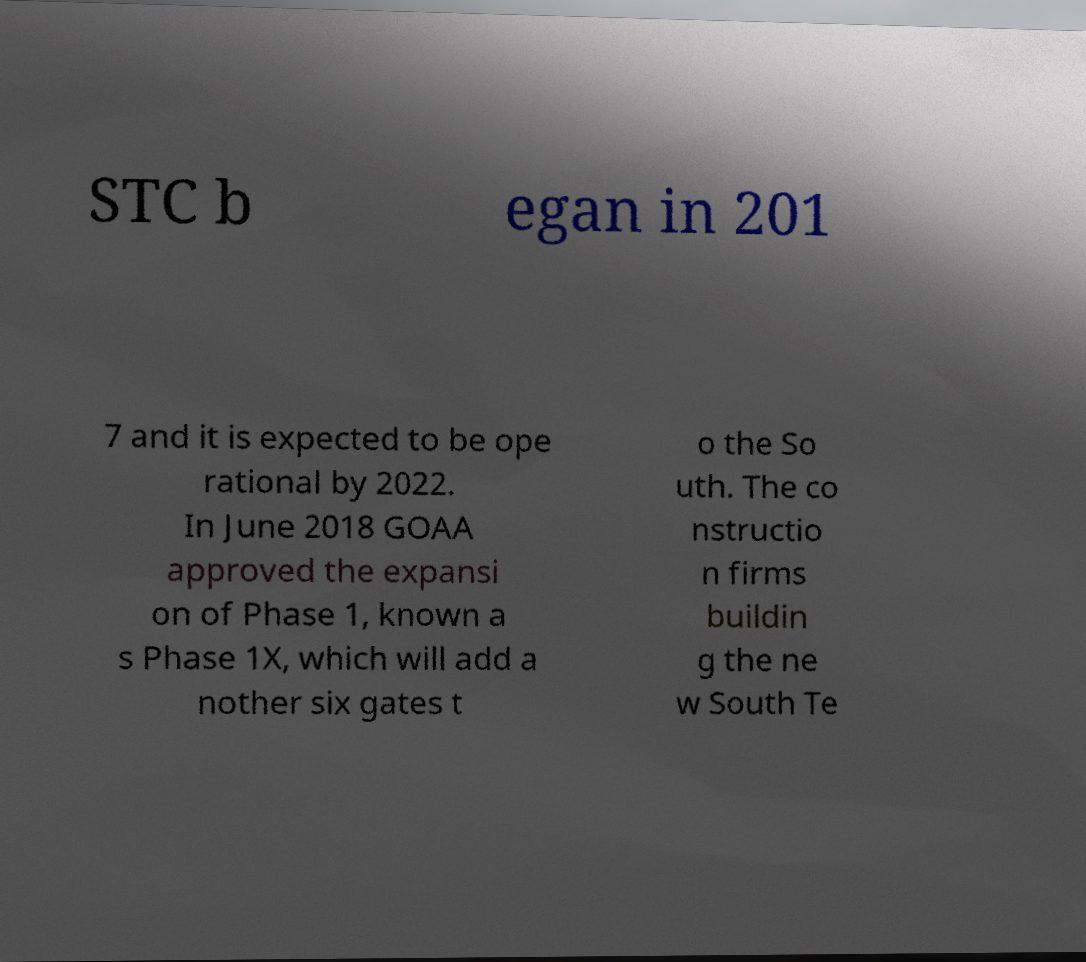Can you read and provide the text displayed in the image?This photo seems to have some interesting text. Can you extract and type it out for me? STC b egan in 201 7 and it is expected to be ope rational by 2022. In June 2018 GOAA approved the expansi on of Phase 1, known a s Phase 1X, which will add a nother six gates t o the So uth. The co nstructio n firms buildin g the ne w South Te 